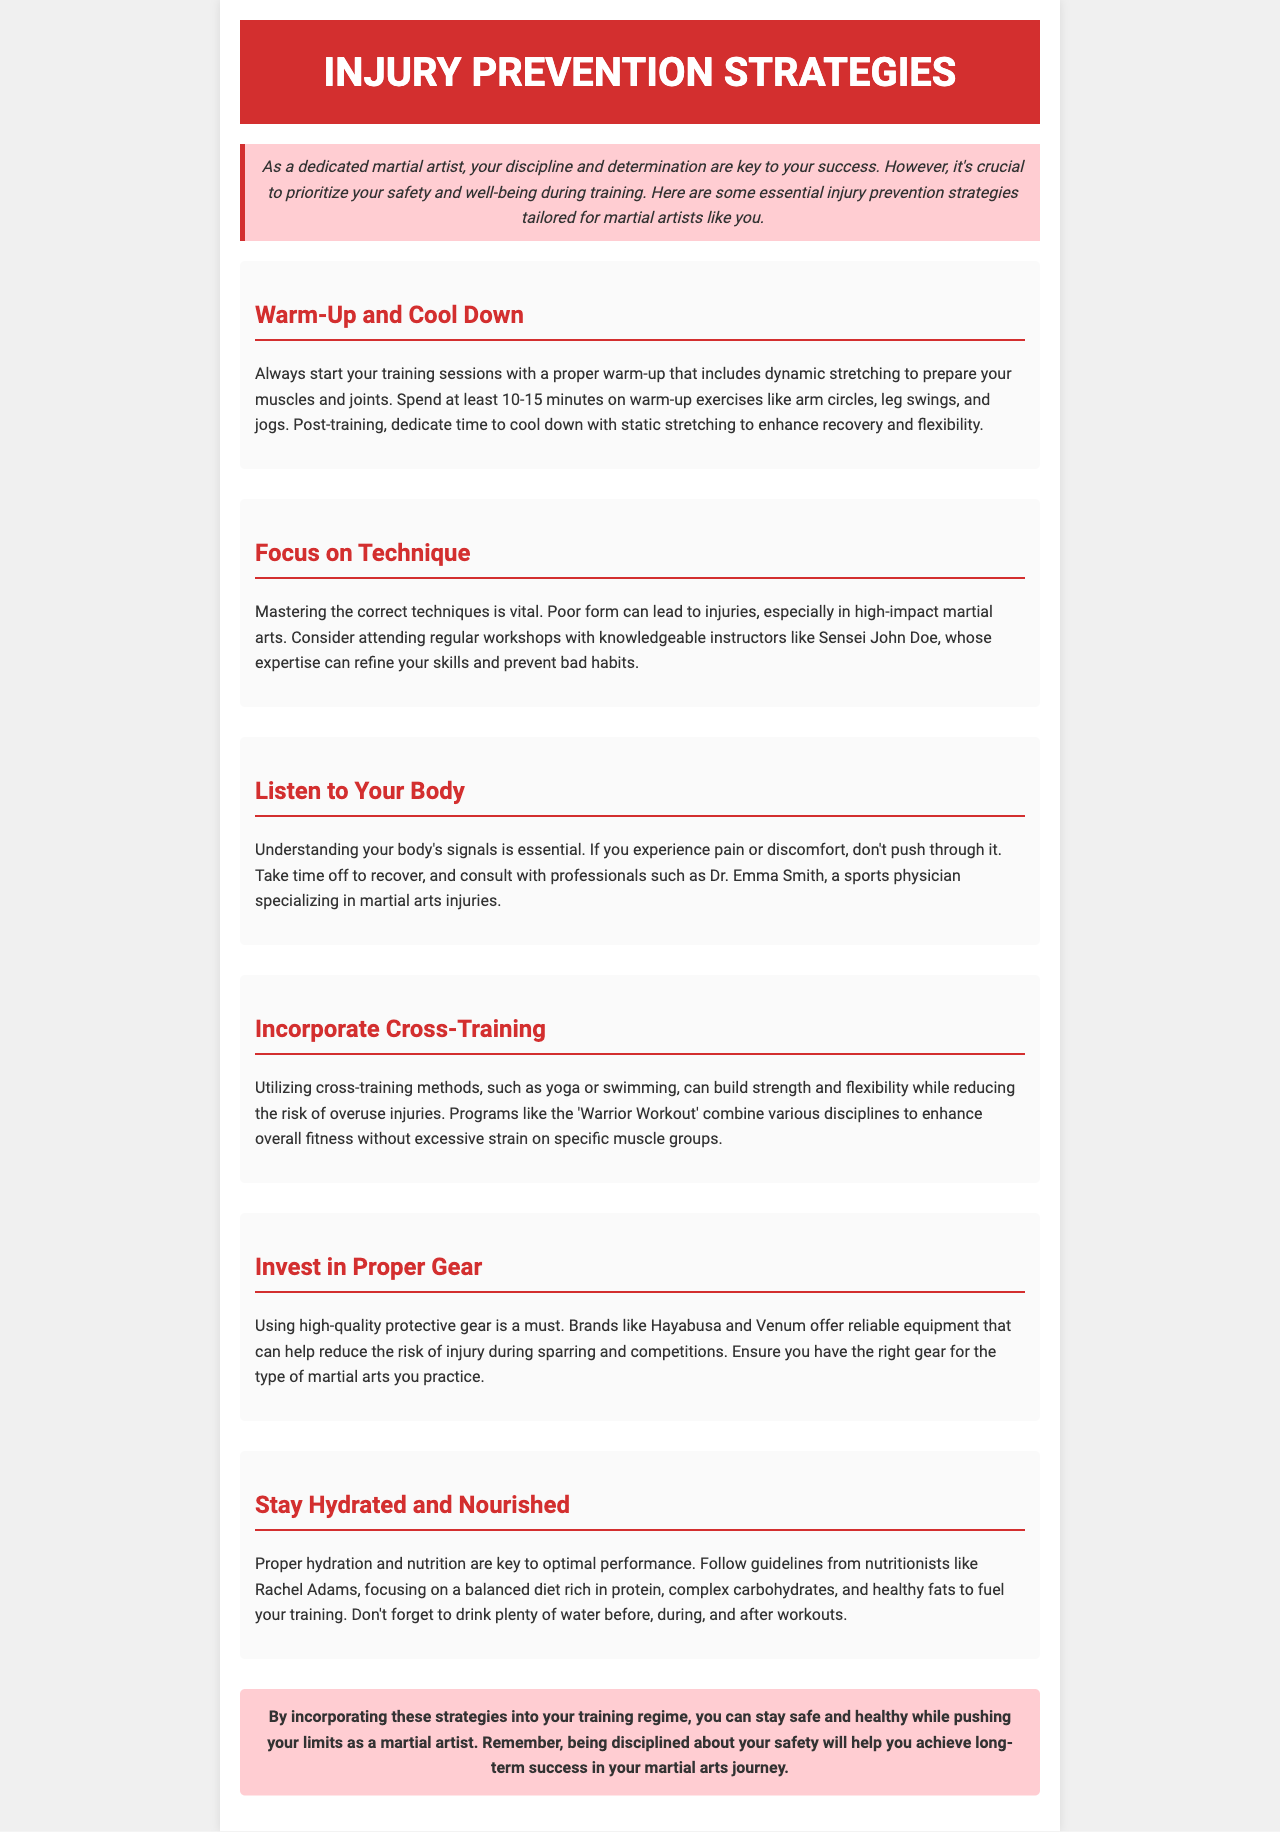What is the first strategy mentioned for injury prevention? The first strategy is about warming up and cooling down properly before and after training sessions.
Answer: Warm-Up and Cool Down Who is a knowledgeable instructor recommended for improving technique? The document mentions Sensei John Doe as a knowledgeable instructor for refining skills and preventing bad habits.
Answer: Sensei John Doe What type of injuries does Dr. Emma Smith specialize in? Dr. Emma Smith specializes in sports injuries related to martial arts.
Answer: Martial arts injuries Which cross-training method is mentioned in the newsletter? The newsletter mentions yoga as a beneficial cross-training method.
Answer: Yoga What should you prioritize along with safety in training? Along with safety, it's essential to prioritize hydration and nutrition during training.
Answer: Hydration and Nutrition Why is it important to listen to your body while training? Understanding your body's signals can help prevent injuries and promote recovery.
Answer: Prevent injuries What kind of gear is recommended to minimize injury risk? The document recommends using high-quality protective gear from brands like Hayabusa and Venum.
Answer: Protective gear How long should a warm-up session last? The newsletter advises spending at least 10-15 minutes on warm-up exercises.
Answer: 10-15 minutes 